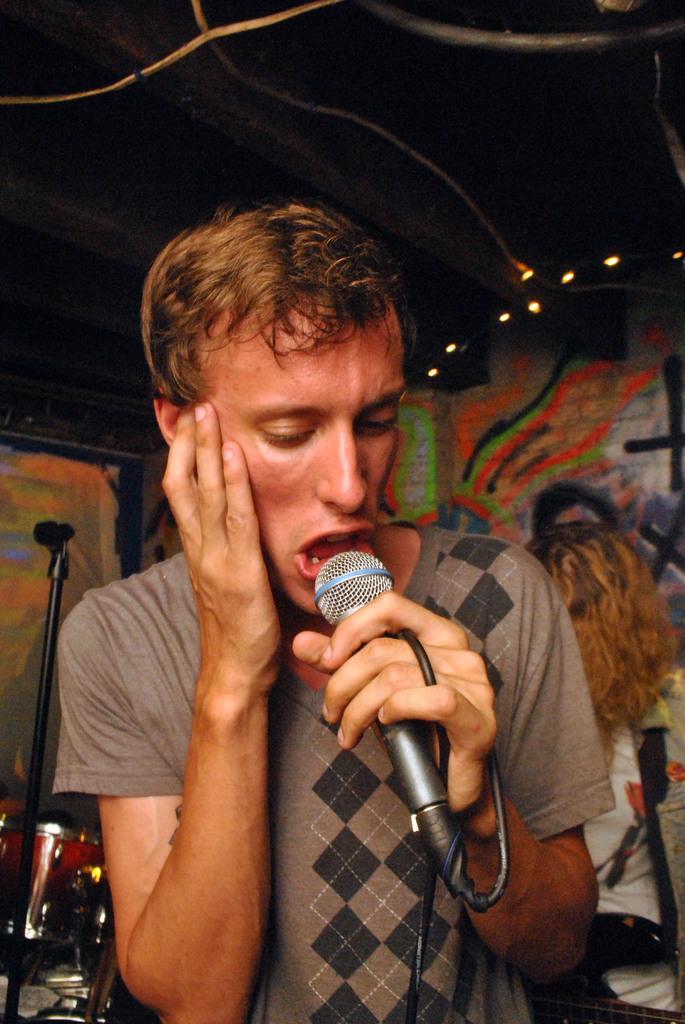Describe this image in one or two sentences. Here is a man, who is holding a microphone in his hand singing, behind him there are drums, there is wall it is painted, here are the lights 